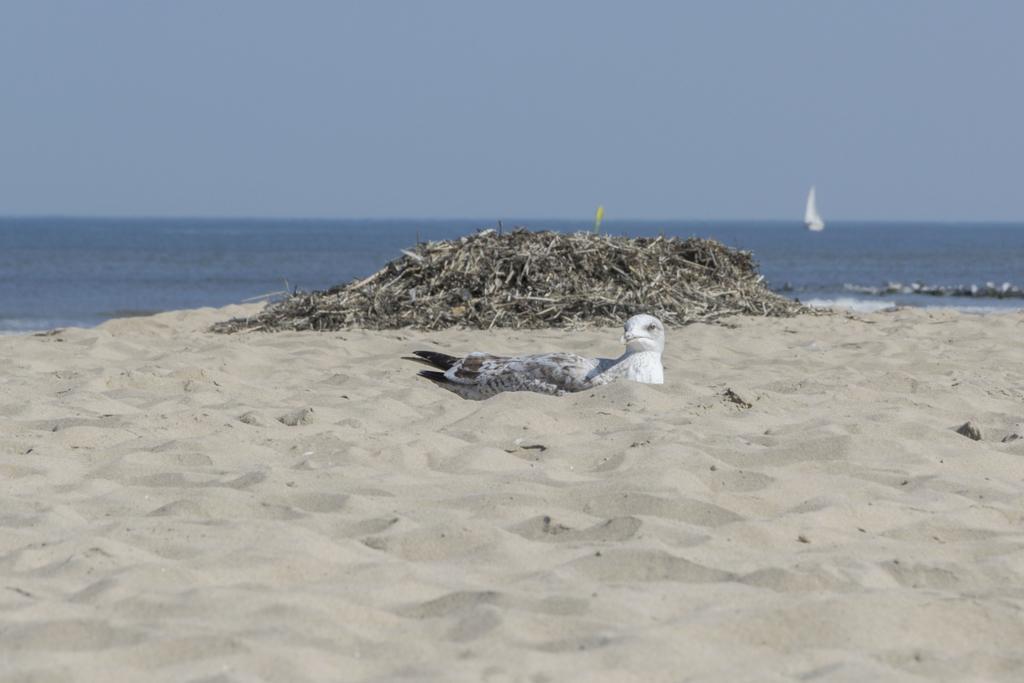Please provide a concise description of this image. In this picture there is a bird on the sand and there is a garbage. At the back there is a boat on the water. At the top there is sky. At the bottom there is sand and water. 